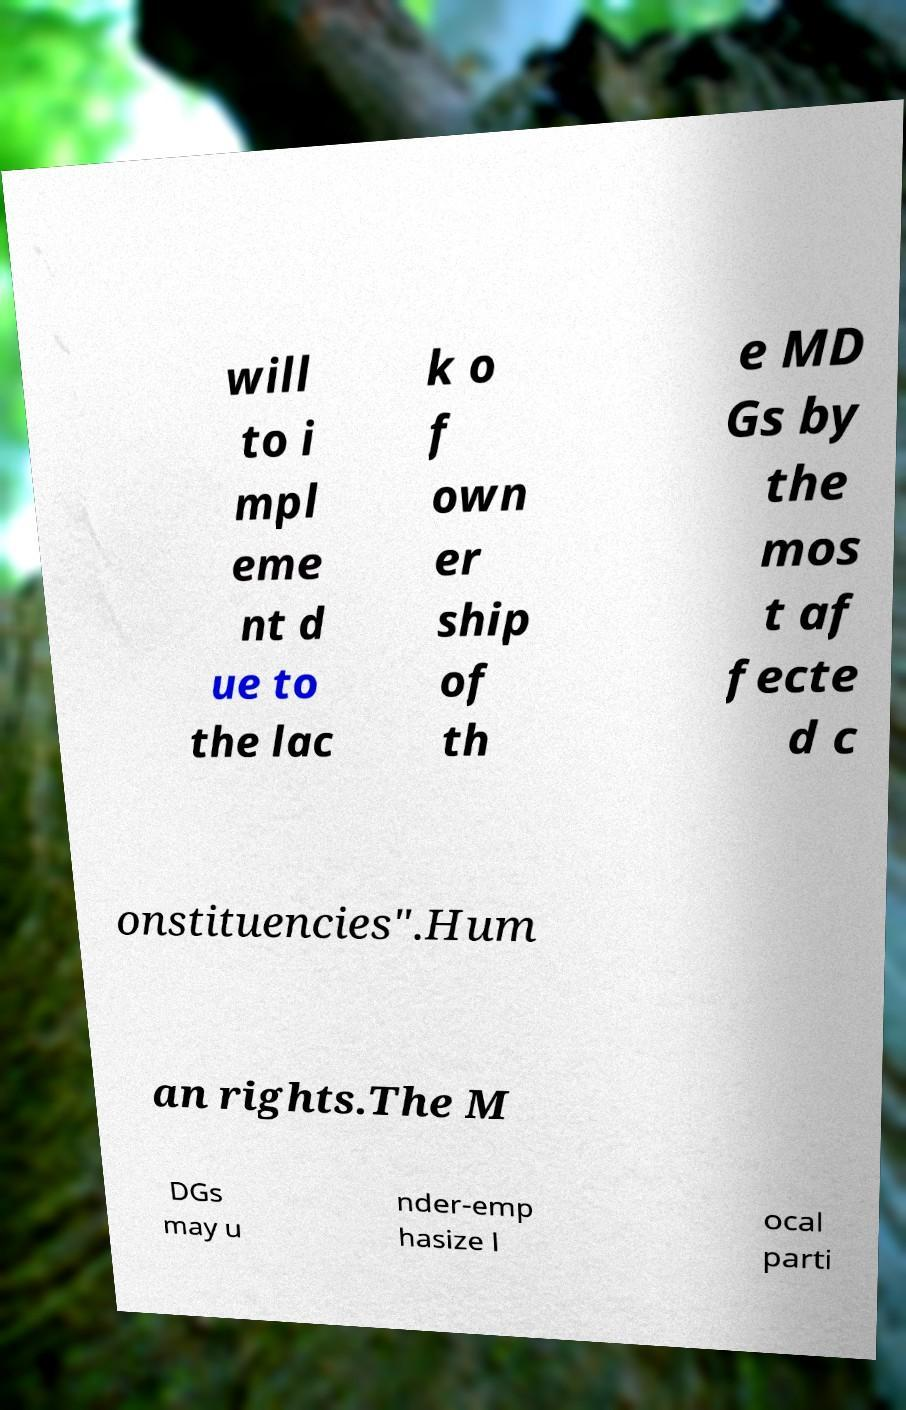I need the written content from this picture converted into text. Can you do that? will to i mpl eme nt d ue to the lac k o f own er ship of th e MD Gs by the mos t af fecte d c onstituencies".Hum an rights.The M DGs may u nder-emp hasize l ocal parti 